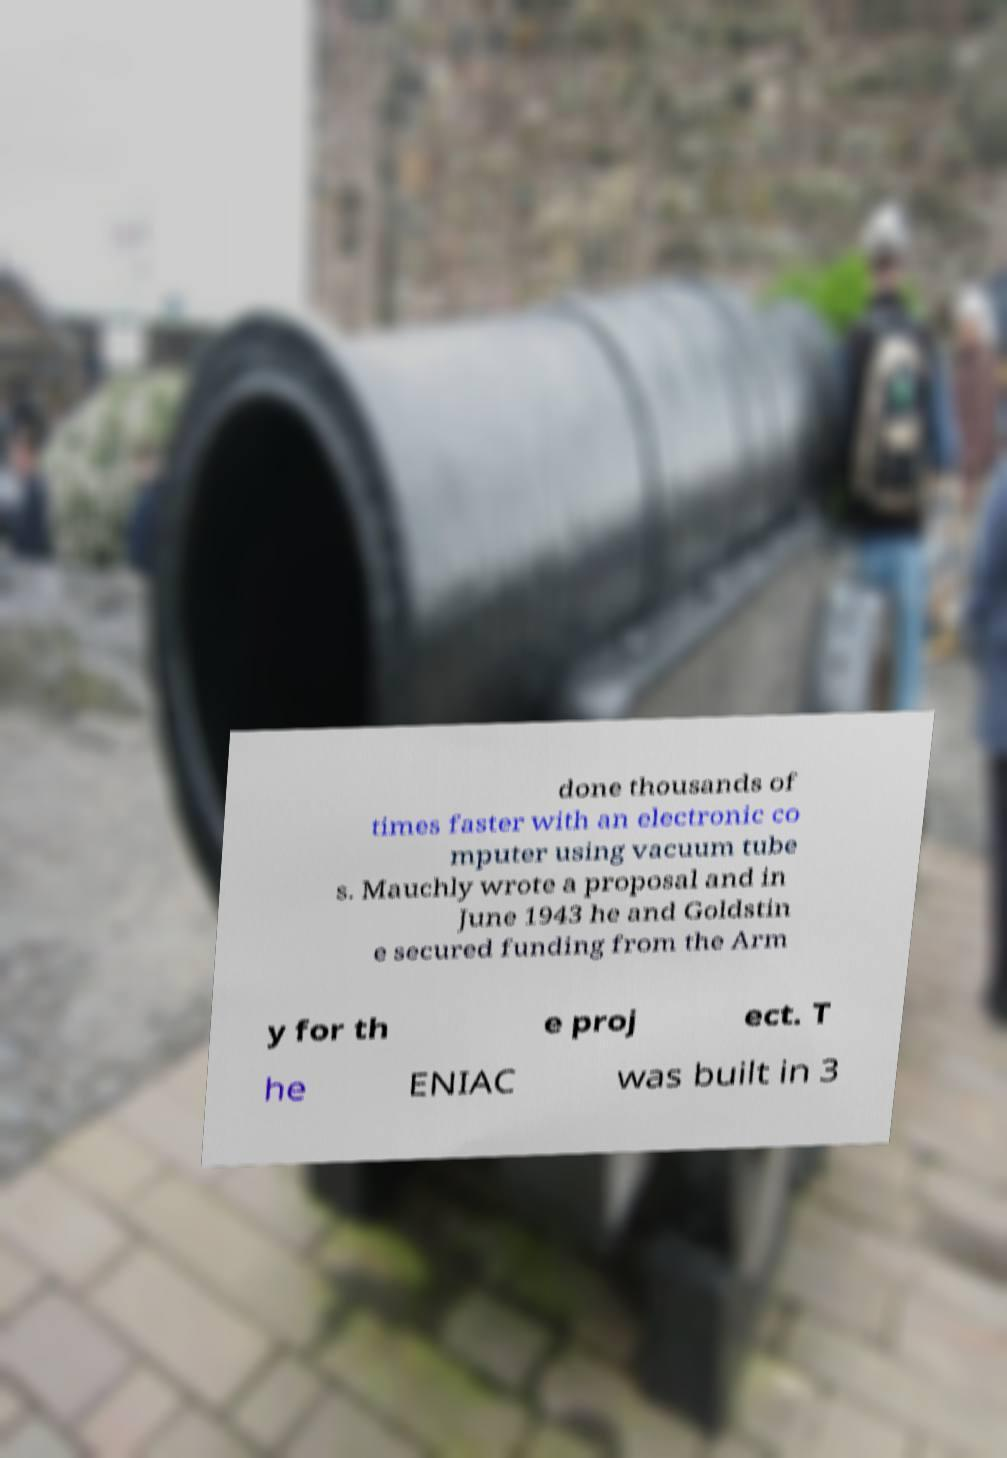What messages or text are displayed in this image? I need them in a readable, typed format. done thousands of times faster with an electronic co mputer using vacuum tube s. Mauchly wrote a proposal and in June 1943 he and Goldstin e secured funding from the Arm y for th e proj ect. T he ENIAC was built in 3 